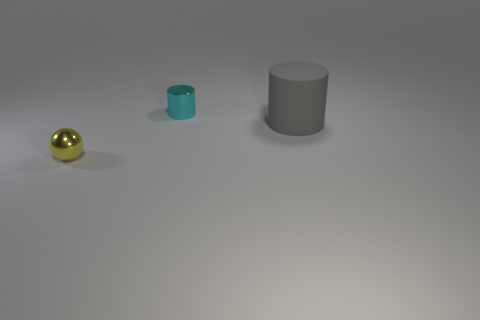Is the shape of the small yellow object the same as the thing to the right of the tiny cyan cylinder?
Give a very brief answer. No. There is a metal thing that is to the left of the cylinder behind the cylinder in front of the tiny cyan cylinder; what color is it?
Give a very brief answer. Yellow. How many objects are either tiny things that are to the right of the yellow sphere or small cylinders behind the small ball?
Provide a short and direct response. 1. What number of other things are the same color as the big rubber cylinder?
Provide a succinct answer. 0. There is a small shiny object behind the tiny sphere; does it have the same shape as the large object?
Provide a short and direct response. Yes. Is the number of tiny metal balls behind the gray cylinder less than the number of metal cylinders?
Keep it short and to the point. Yes. Are there any other cylinders that have the same material as the small cyan cylinder?
Ensure brevity in your answer.  No. Are there fewer small yellow things on the right side of the big object than small objects that are on the left side of the yellow sphere?
Your response must be concise. No. There is a thing that is in front of the tiny cyan cylinder and behind the tiny yellow ball; what is its shape?
Ensure brevity in your answer.  Cylinder. What number of small brown things have the same shape as the gray thing?
Ensure brevity in your answer.  0. 